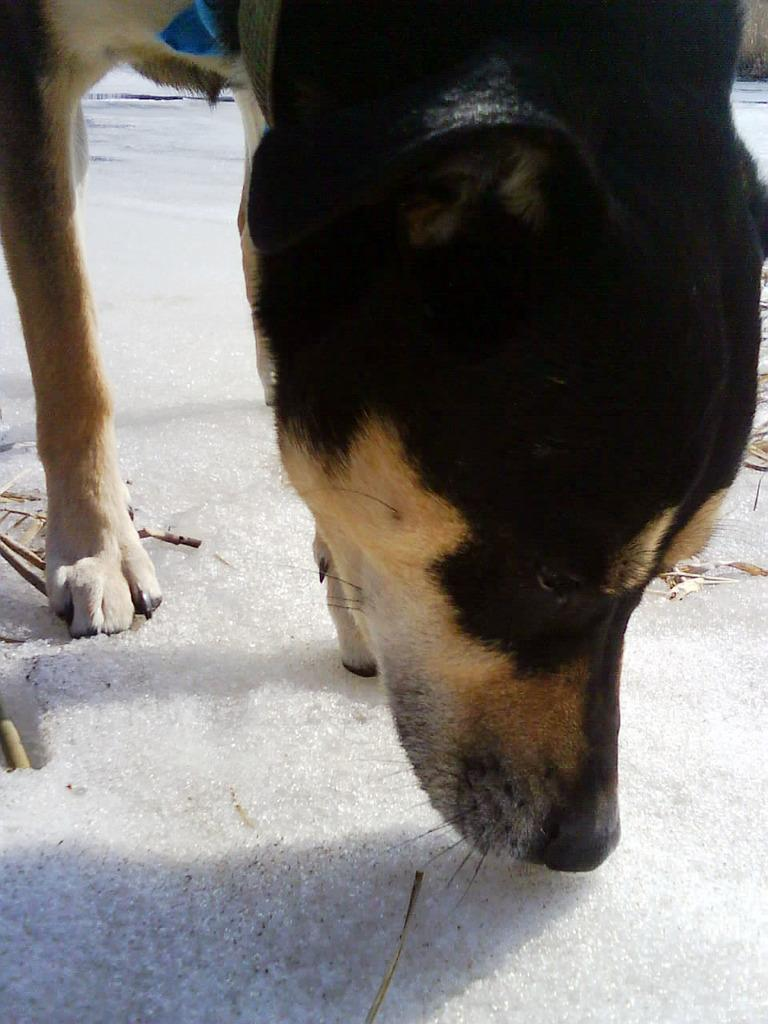What animal is present in the image? There is a dog in the image. Where is the dog located? The dog is on the ground. What is covering the ground in the image? The ground is covered with snow. How many mittens can be seen in the image? There are no mittens present in the image. Is there a lake visible in the image? There is no lake visible in the image. 